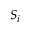Convert formula to latex. <formula><loc_0><loc_0><loc_500><loc_500>S _ { i }</formula> 